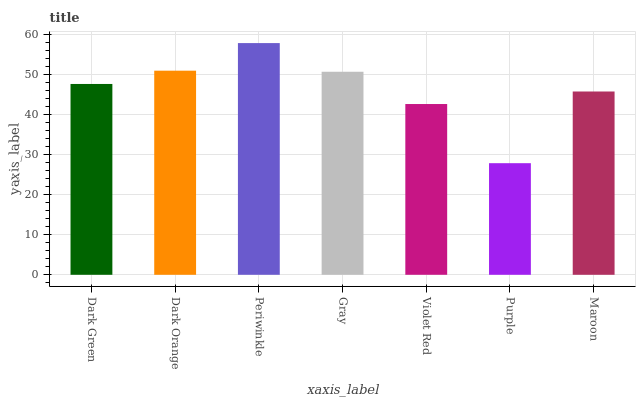Is Purple the minimum?
Answer yes or no. Yes. Is Periwinkle the maximum?
Answer yes or no. Yes. Is Dark Orange the minimum?
Answer yes or no. No. Is Dark Orange the maximum?
Answer yes or no. No. Is Dark Orange greater than Dark Green?
Answer yes or no. Yes. Is Dark Green less than Dark Orange?
Answer yes or no. Yes. Is Dark Green greater than Dark Orange?
Answer yes or no. No. Is Dark Orange less than Dark Green?
Answer yes or no. No. Is Dark Green the high median?
Answer yes or no. Yes. Is Dark Green the low median?
Answer yes or no. Yes. Is Violet Red the high median?
Answer yes or no. No. Is Violet Red the low median?
Answer yes or no. No. 